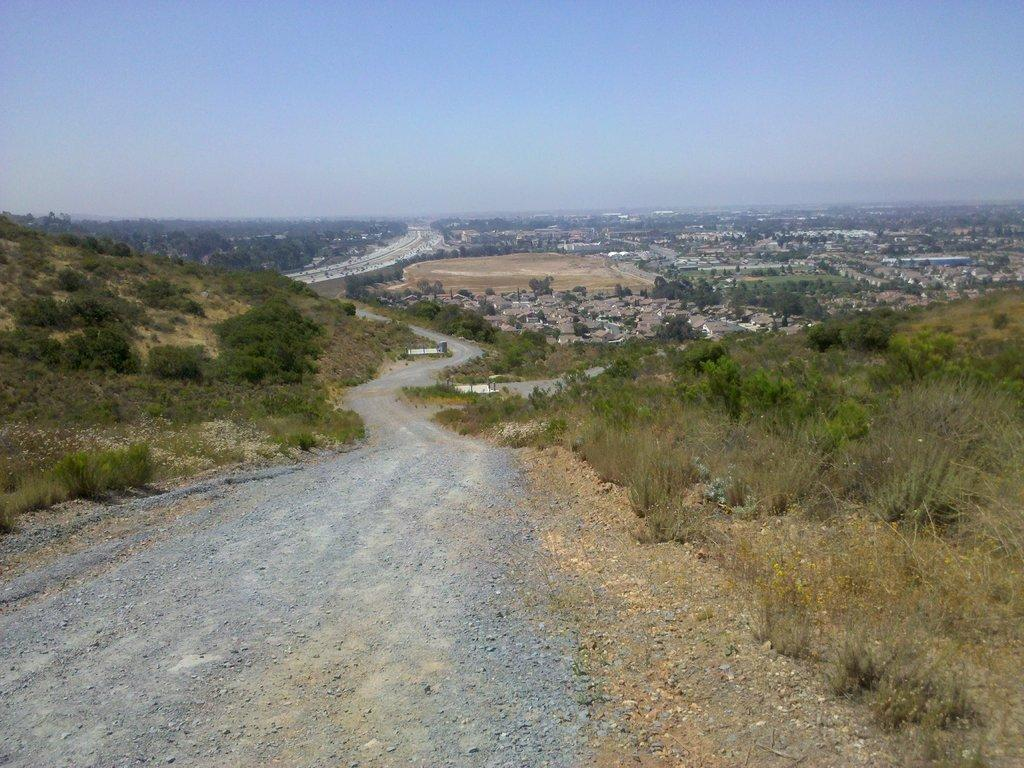What is the main feature of the image? There is a way or path in the picture. What can be seen on either side of the path? There is greenery on either side of the path. What is visible in the background of the image? There are buildings and trees in the background of the picture. What type of glass is being used to construct the buildings in the image? There is no information about the type of glass used in the construction of the buildings in the image. 